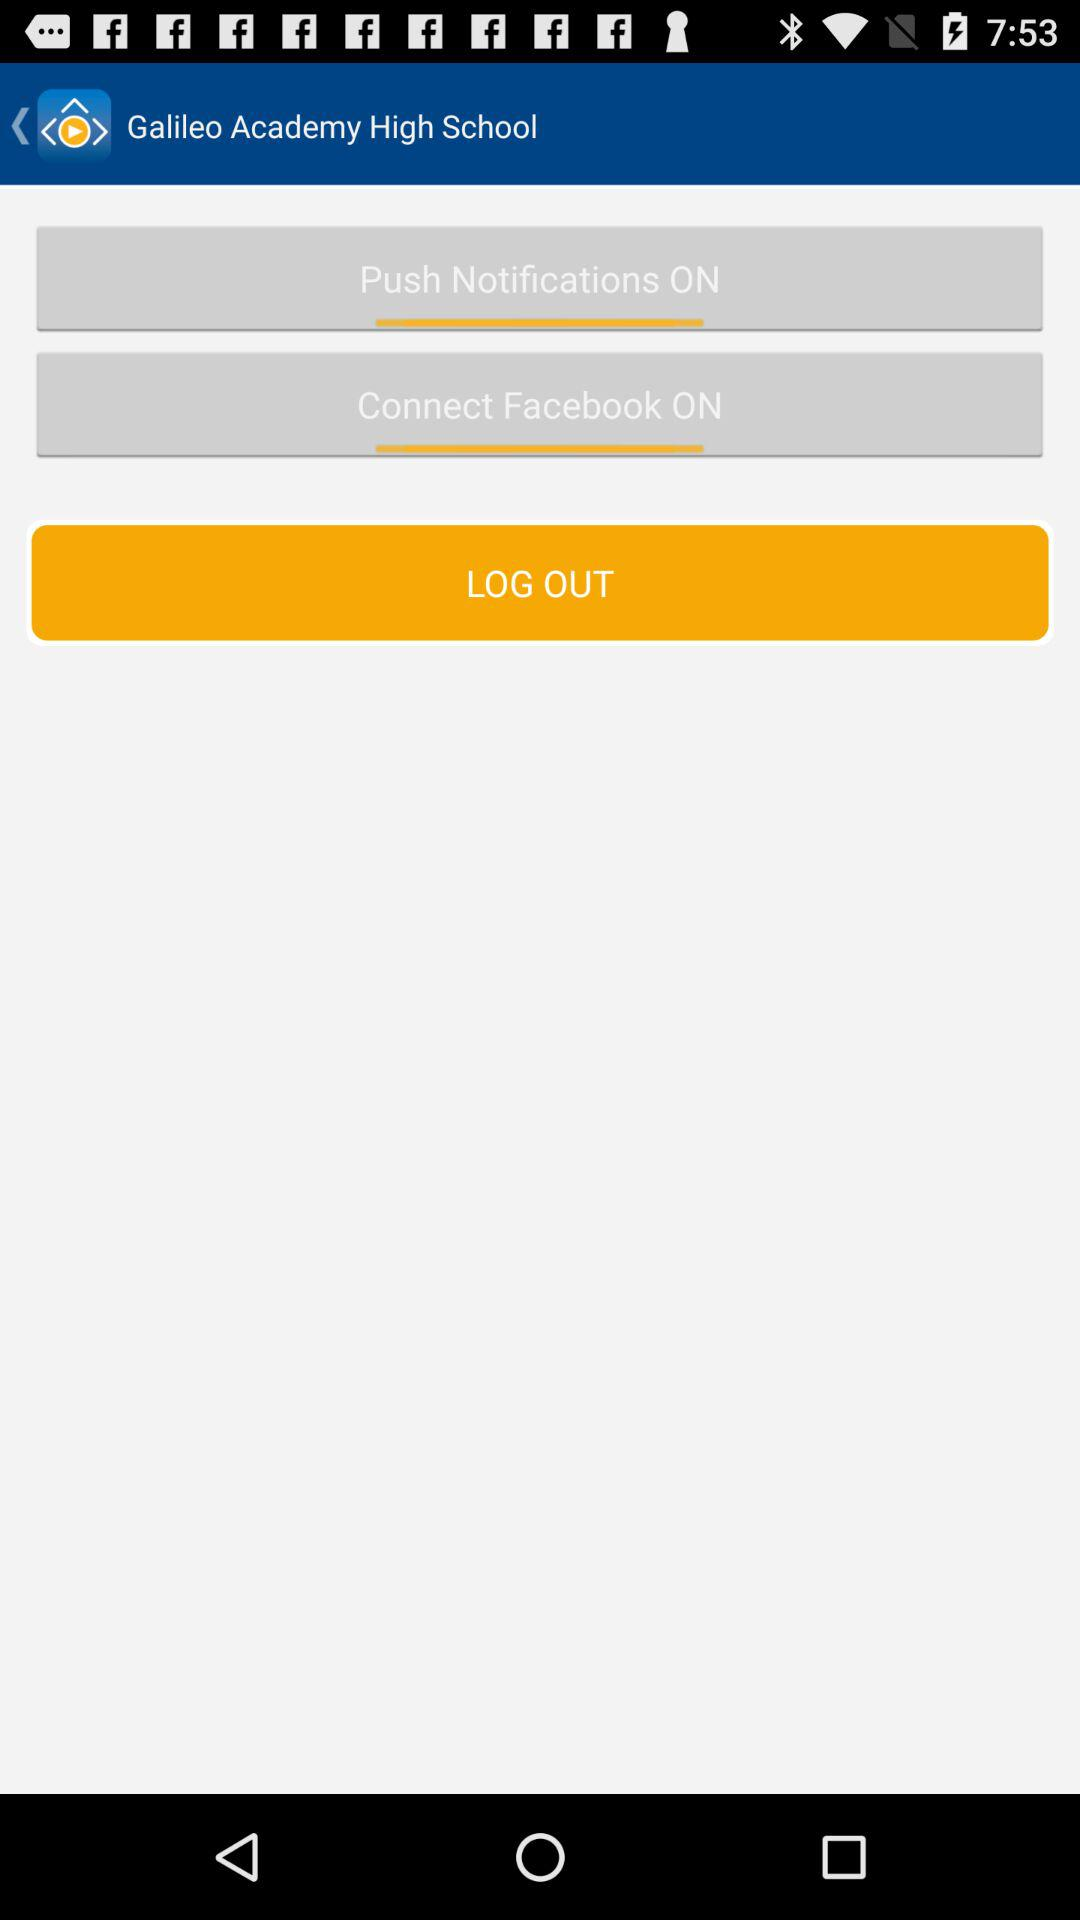What is the name of the school? The name of the school is Galileo Academy High School. 